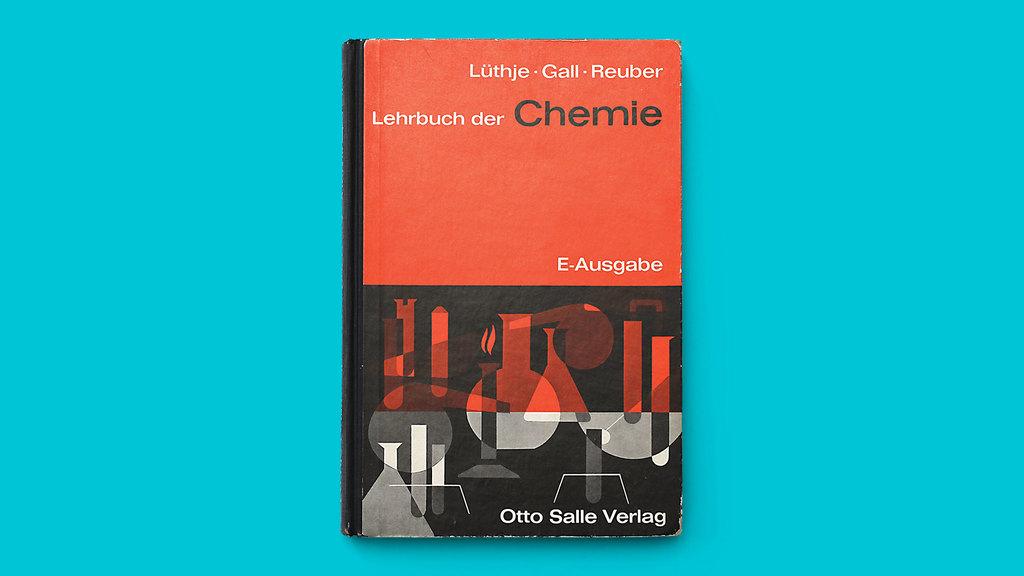What is the title of the book?
Your answer should be very brief. Lehrbuch der chemie. 